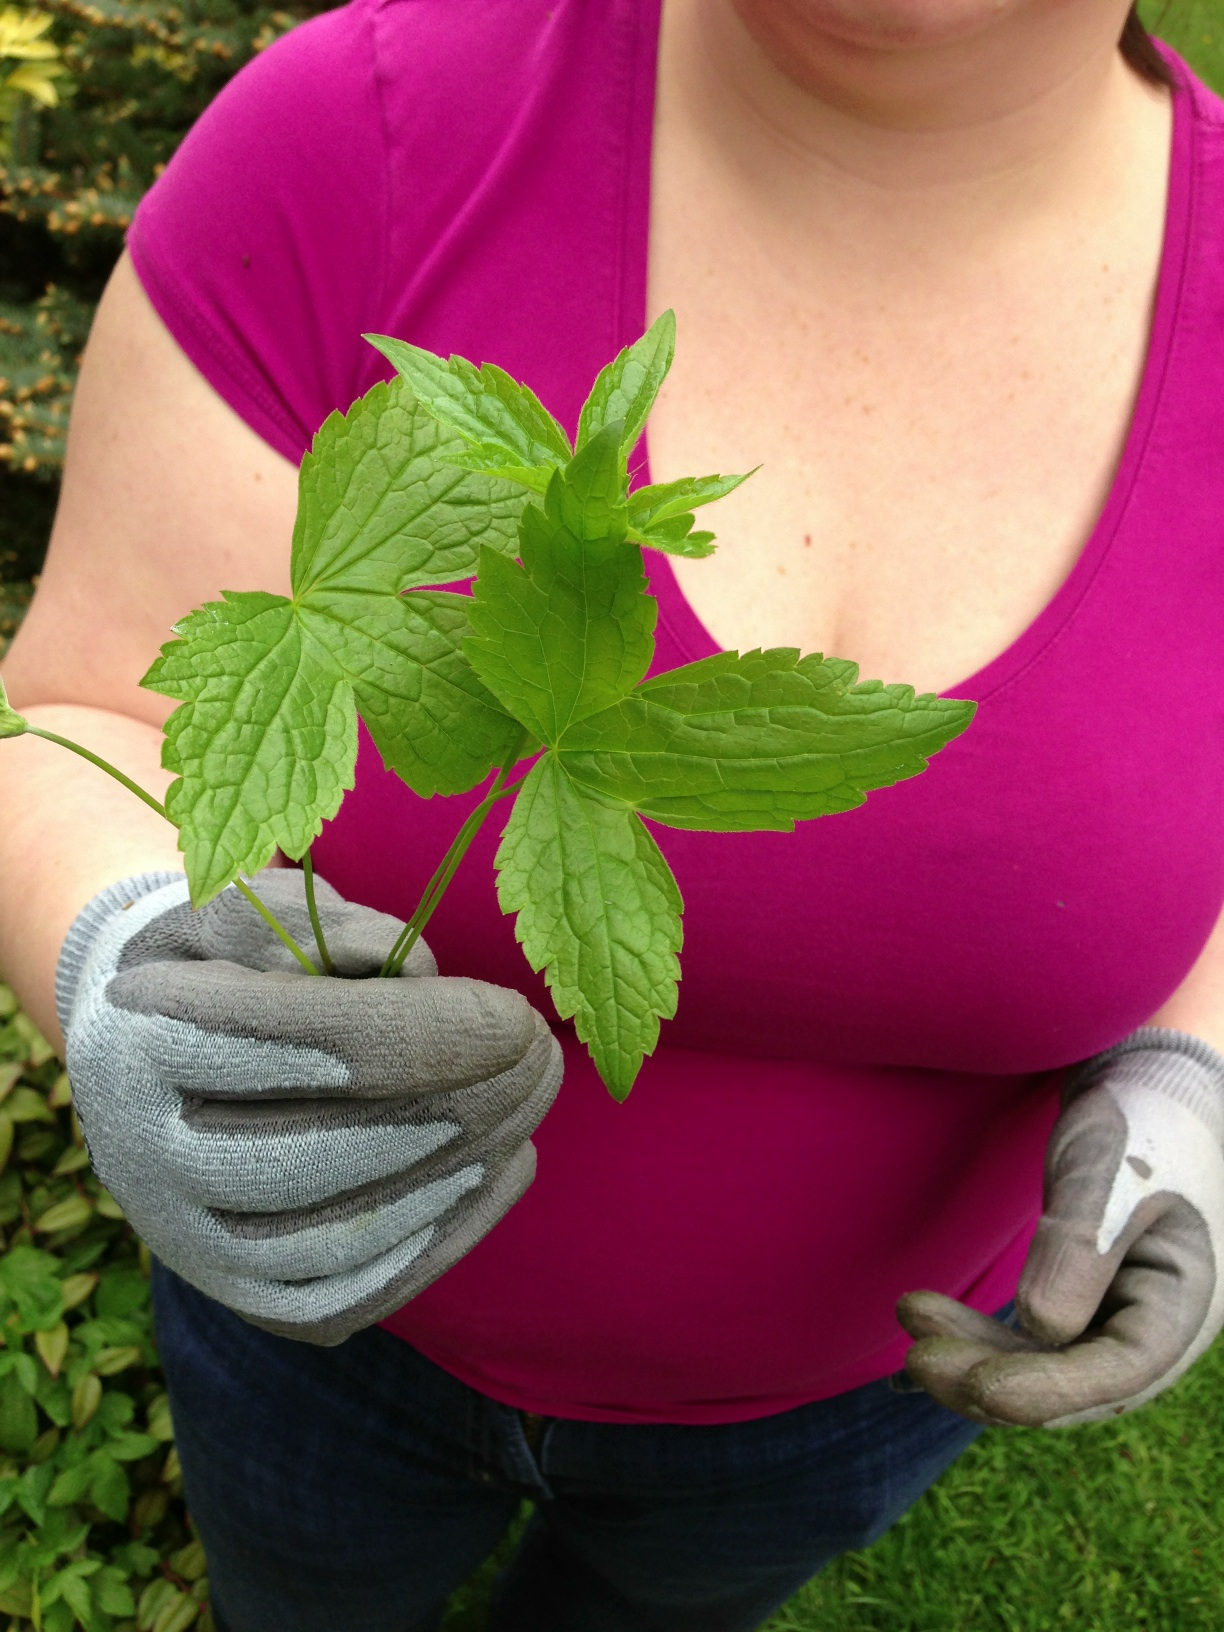What kind of plant is this? The plant you are holding appears to be a type of herb, possibly ginseng or a similar variety. It’s distinguished by its compound leaves with three parts, which are common to several medicinal plants. Understanding its exact species would require more context about its natural habitat or additional plant features. 